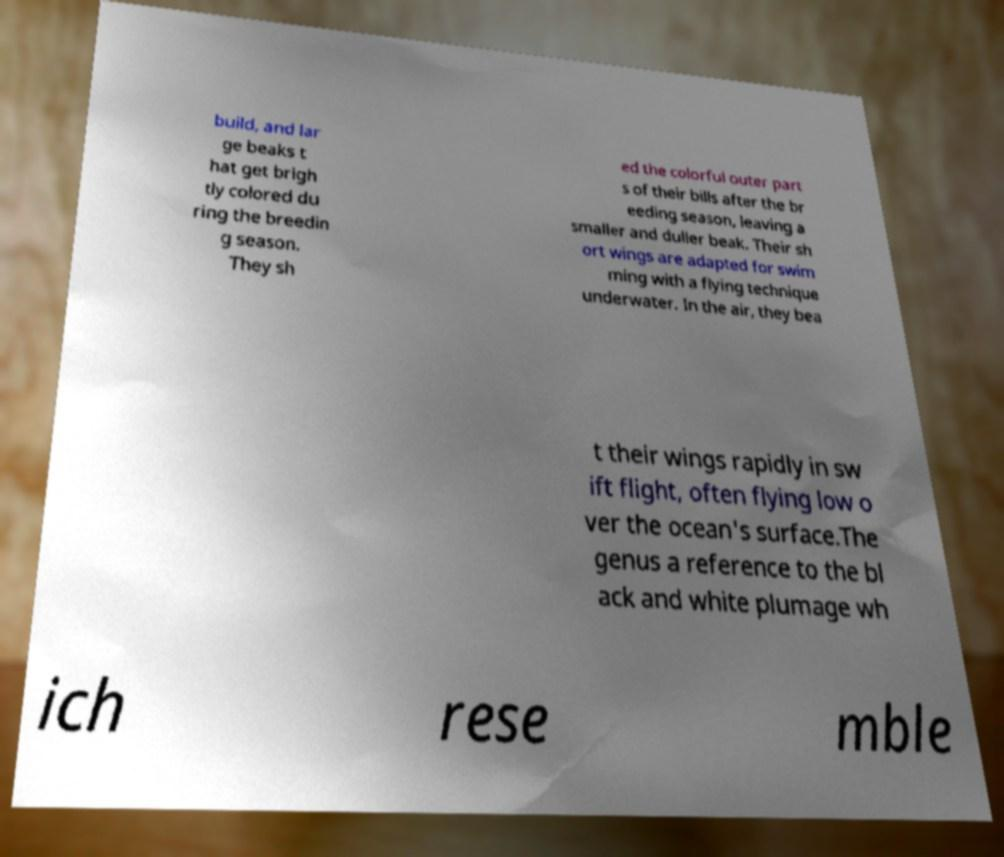For documentation purposes, I need the text within this image transcribed. Could you provide that? build, and lar ge beaks t hat get brigh tly colored du ring the breedin g season. They sh ed the colorful outer part s of their bills after the br eeding season, leaving a smaller and duller beak. Their sh ort wings are adapted for swim ming with a flying technique underwater. In the air, they bea t their wings rapidly in sw ift flight, often flying low o ver the ocean's surface.The genus a reference to the bl ack and white plumage wh ich rese mble 